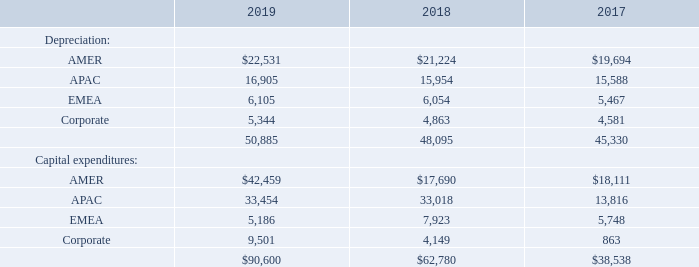11. Reportable Segments, Geographic Information and Major Customers
Reportable segments are defined as components of an enterprise about which separate financial information is available that is evaluated regularly by the chief operating decision maker, or group, in assessing performance and allocating resources. The Company uses an internal management reporting system, which provides important financial data to evaluate performance and allocate the Company’s resources on a regional basis. Net sales for the segments are attributed to the region in which the product is manufactured or the service is performed. The services provided, manufacturing processes used, class of customers serviced and order fulfillment processes used are similar and generally interchangeable across the segments. A segment’s performance is evaluated based upon its operating income (loss). A segment’s operating income (loss) includes its net sales less cost of sales and selling and administrative expenses, but excludes corporate and other expenses. Corporate and other expenses  fiscal 2019 and the $13.5 million one-time employee bonus paid to full-time, non-executive employees during fiscal 2018 due to the Company's ability to access overseas cash as a result of Tax Reform (the "one-time employee bonus"). These costs are not allocated to the segments, as management excludes such costs when assessing the performance of the segments. Inter-segment transactions are generally recorded at amounts that approximate arm’s length transactions. The accounting policies for the segments are the same as for the Company taken as a whole.
Information about the Company’s three reportable segments for fiscal 2019, 2018 and 2017 is as follows (in thousands):
What was the depreciation from AMER in 2017?
Answer scale should be: thousand. 19,694. What was the depreciation from APAC in 2018?
Answer scale should be: thousand. 15,954. What was the Corporate depreciation in 2019?
Answer scale should be: thousand. 5,344. How many years did depreciation from APAC exceed $15,000 thousand instead? 2019##2018##2017
Answer: 3. What was the change in Corporate Depreciation between 2018 and 2019?
Answer scale should be: thousand. 5,344-4,863
Answer: 481. What was the percentage change in the total depreciation between 2017 and 2018?
Answer scale should be: percent. (48,095-45,330)/45,330
Answer: 6.1. 